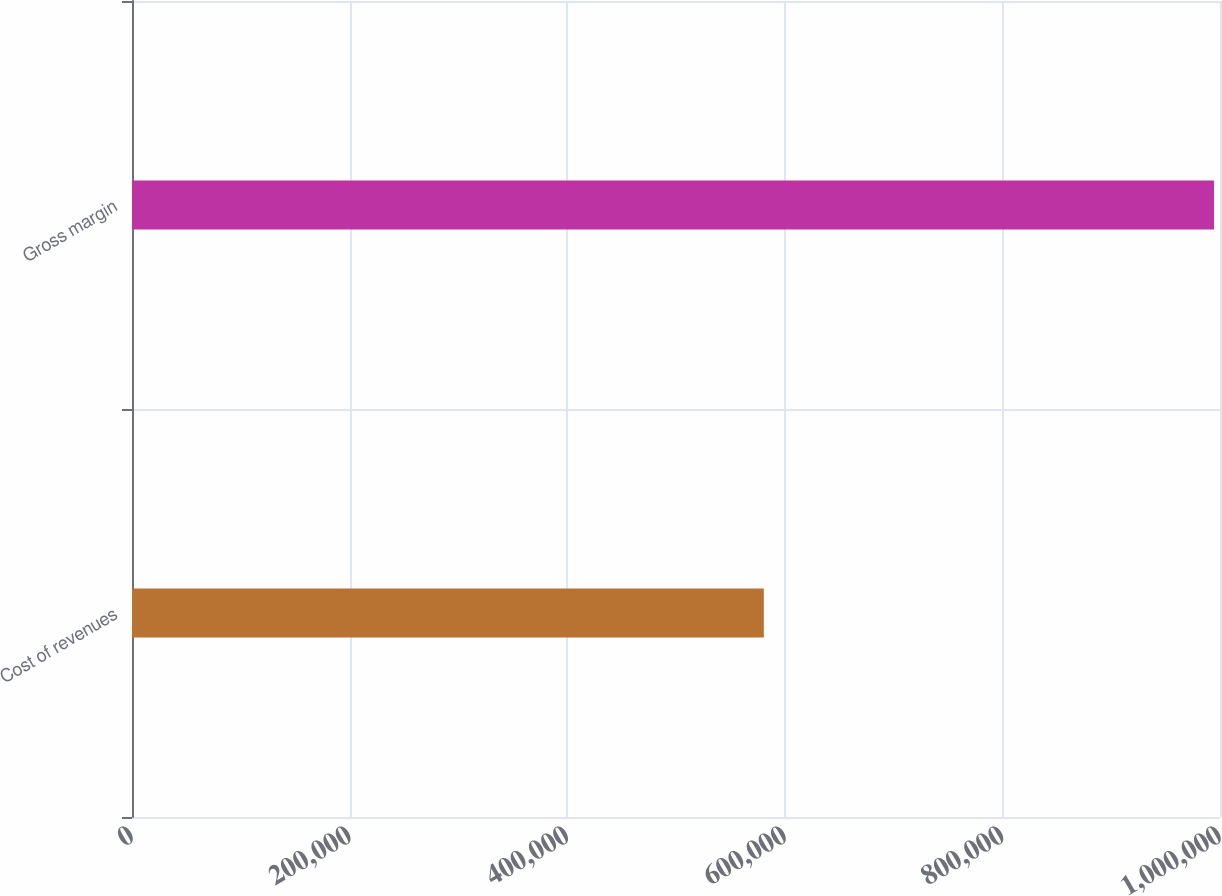<chart> <loc_0><loc_0><loc_500><loc_500><bar_chart><fcel>Cost of revenues<fcel>Gross margin<nl><fcel>580739<fcel>994510<nl></chart> 